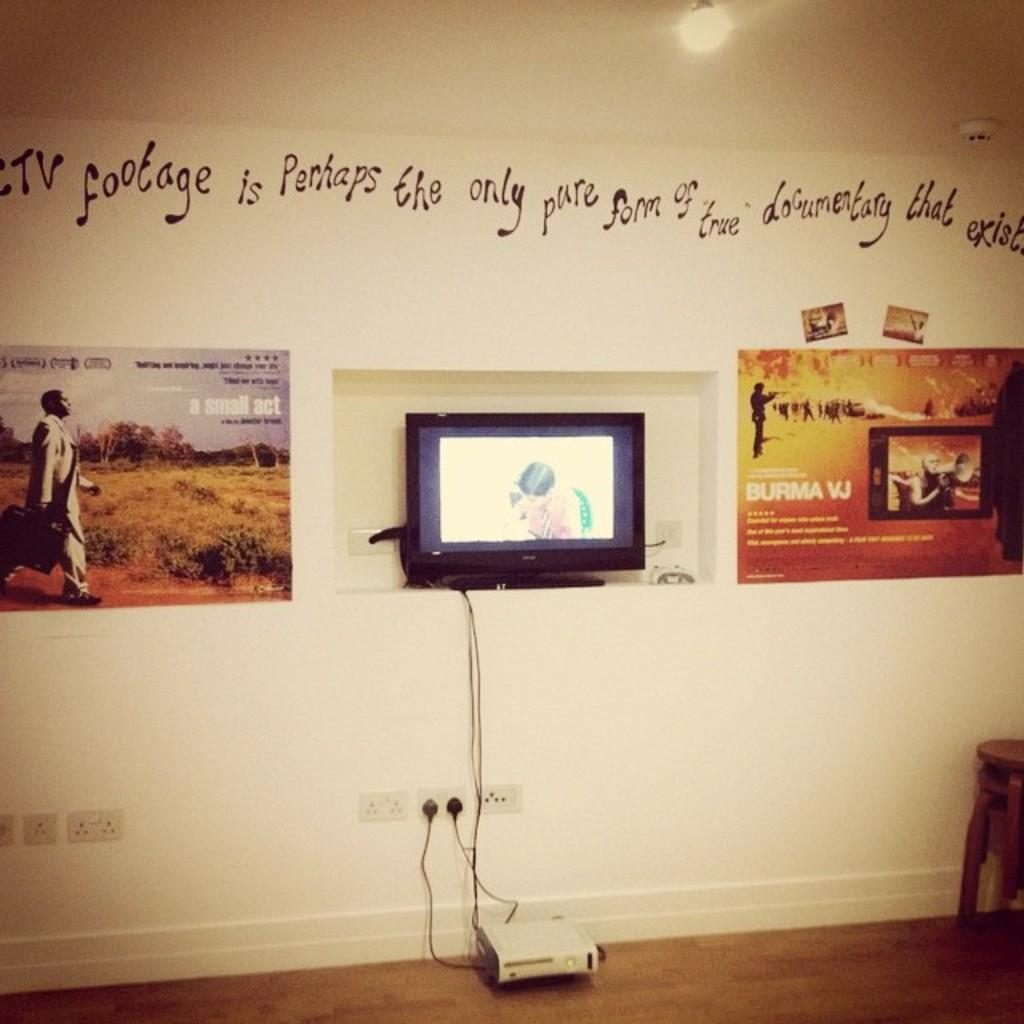<image>
Present a compact description of the photo's key features. A bright-colored banner describes something called "Burma VJ." 